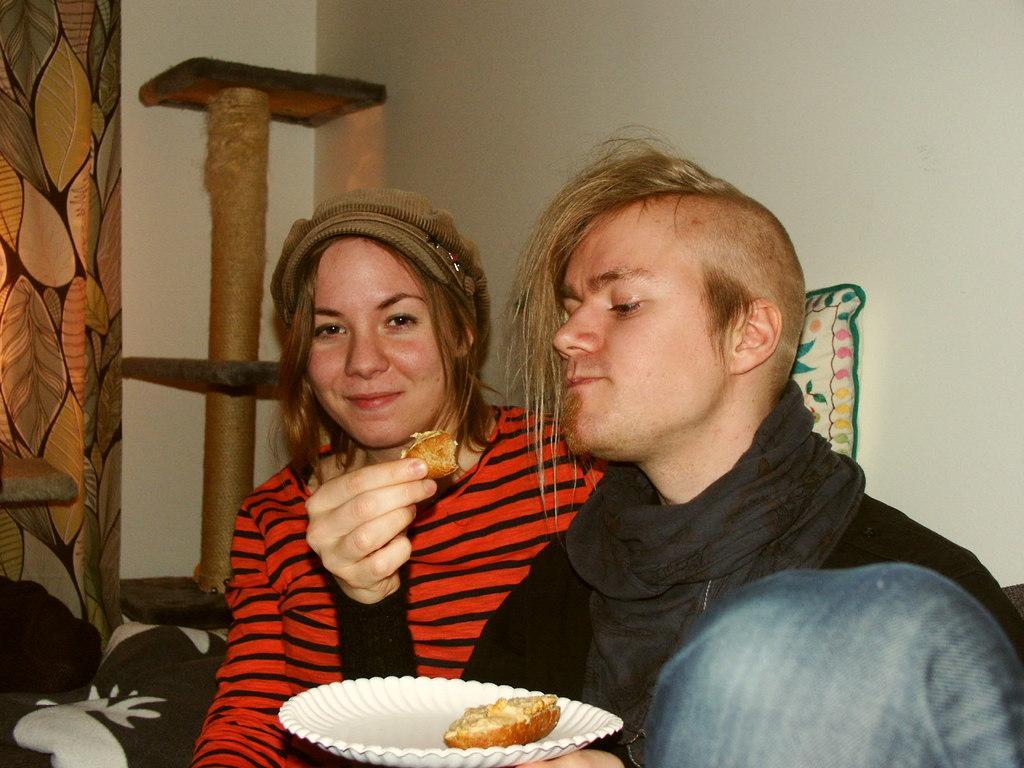How would you summarize this image in a sentence or two? In this image there is a person sitting and holding a food item and a plate, there is another person sitting beside him, pillow, wall poster, clothes, wall. 